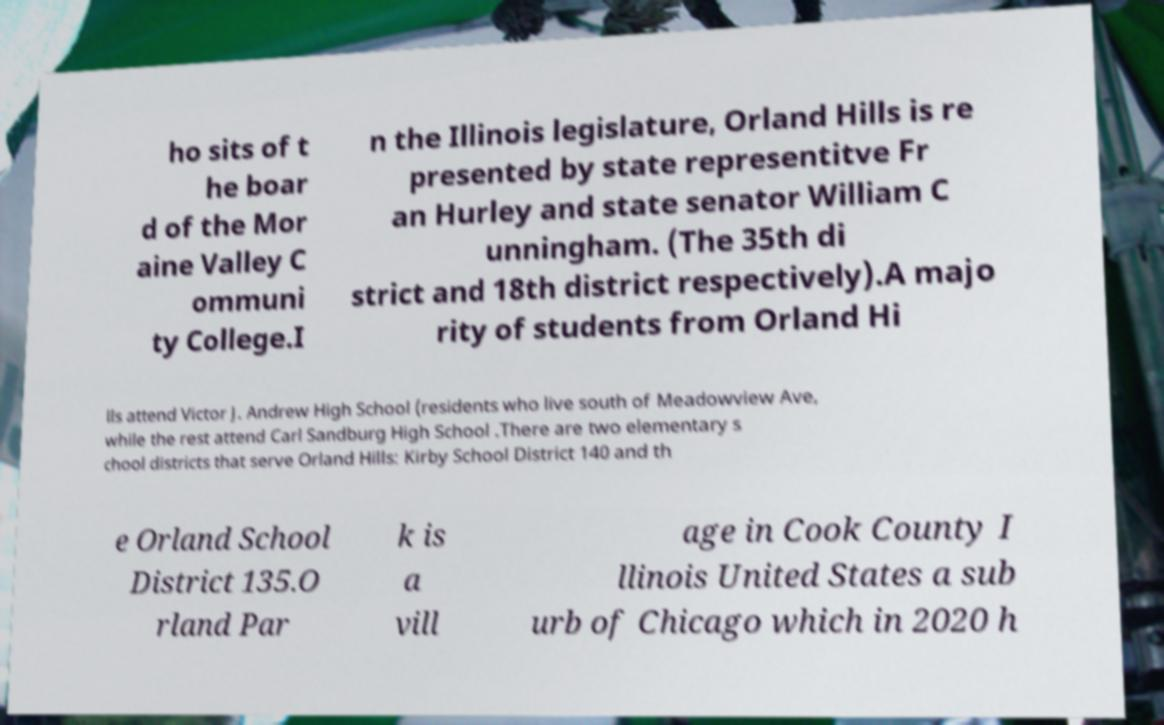I need the written content from this picture converted into text. Can you do that? ho sits of t he boar d of the Mor aine Valley C ommuni ty College.I n the Illinois legislature, Orland Hills is re presented by state representitve Fr an Hurley and state senator William C unningham. (The 35th di strict and 18th district respectively).A majo rity of students from Orland Hi lls attend Victor J. Andrew High School (residents who live south of Meadowview Ave, while the rest attend Carl Sandburg High School .There are two elementary s chool districts that serve Orland Hills: Kirby School District 140 and th e Orland School District 135.O rland Par k is a vill age in Cook County I llinois United States a sub urb of Chicago which in 2020 h 